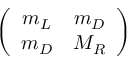<formula> <loc_0><loc_0><loc_500><loc_500>\left ( \begin{array} { c c } { { m _ { L } } } & { { m _ { D } } } \\ { { m _ { D } } } & { { M _ { R } } } \end{array} \right )</formula> 